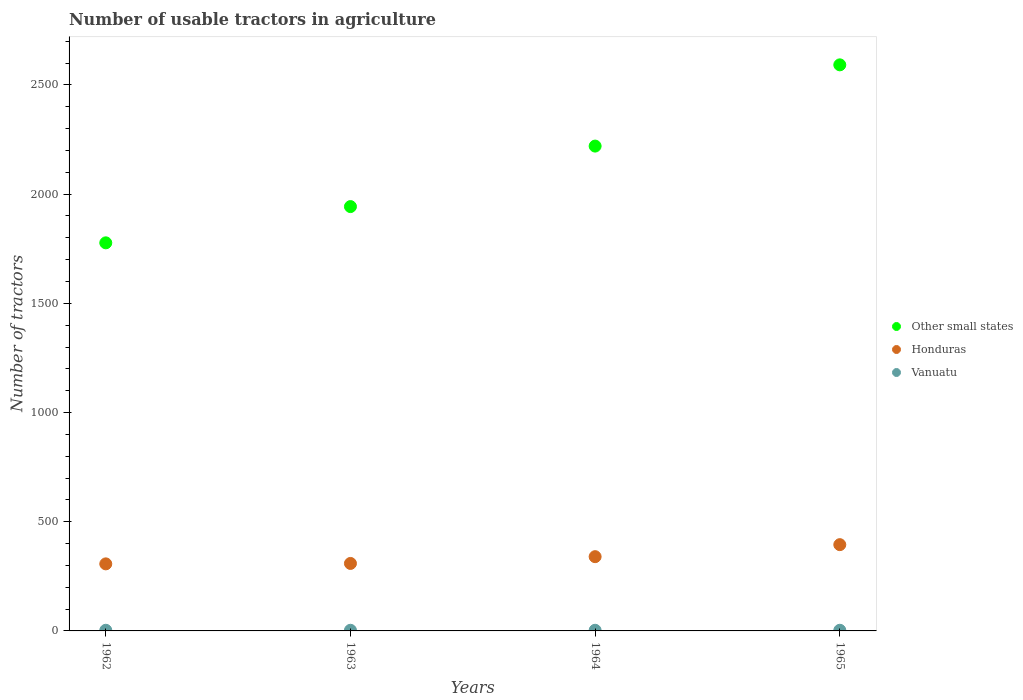How many different coloured dotlines are there?
Offer a terse response. 3. What is the number of usable tractors in agriculture in Other small states in 1964?
Your answer should be compact. 2220. Across all years, what is the maximum number of usable tractors in agriculture in Vanuatu?
Ensure brevity in your answer.  3. In which year was the number of usable tractors in agriculture in Vanuatu maximum?
Provide a succinct answer. 1962. What is the total number of usable tractors in agriculture in Vanuatu in the graph?
Give a very brief answer. 12. What is the difference between the number of usable tractors in agriculture in Honduras in 1964 and that in 1965?
Your answer should be compact. -55. What is the difference between the number of usable tractors in agriculture in Honduras in 1965 and the number of usable tractors in agriculture in Other small states in 1964?
Your answer should be compact. -1825. What is the average number of usable tractors in agriculture in Other small states per year?
Provide a short and direct response. 2133. In the year 1962, what is the difference between the number of usable tractors in agriculture in Other small states and number of usable tractors in agriculture in Vanuatu?
Offer a terse response. 1774. In how many years, is the number of usable tractors in agriculture in Other small states greater than 100?
Your answer should be very brief. 4. What is the ratio of the number of usable tractors in agriculture in Other small states in 1963 to that in 1965?
Make the answer very short. 0.75. Is the number of usable tractors in agriculture in Other small states in 1962 less than that in 1964?
Offer a terse response. Yes. What is the difference between the highest and the second highest number of usable tractors in agriculture in Other small states?
Offer a very short reply. 372. Is it the case that in every year, the sum of the number of usable tractors in agriculture in Vanuatu and number of usable tractors in agriculture in Other small states  is greater than the number of usable tractors in agriculture in Honduras?
Keep it short and to the point. Yes. Does the number of usable tractors in agriculture in Honduras monotonically increase over the years?
Your answer should be compact. Yes. Is the number of usable tractors in agriculture in Honduras strictly greater than the number of usable tractors in agriculture in Vanuatu over the years?
Ensure brevity in your answer.  Yes. How many dotlines are there?
Give a very brief answer. 3. Does the graph contain any zero values?
Give a very brief answer. No. Does the graph contain grids?
Keep it short and to the point. No. Where does the legend appear in the graph?
Make the answer very short. Center right. What is the title of the graph?
Provide a succinct answer. Number of usable tractors in agriculture. What is the label or title of the Y-axis?
Your response must be concise. Number of tractors. What is the Number of tractors of Other small states in 1962?
Ensure brevity in your answer.  1777. What is the Number of tractors of Honduras in 1962?
Provide a succinct answer. 307. What is the Number of tractors in Other small states in 1963?
Keep it short and to the point. 1943. What is the Number of tractors in Honduras in 1963?
Offer a very short reply. 309. What is the Number of tractors in Vanuatu in 1963?
Offer a very short reply. 3. What is the Number of tractors of Other small states in 1964?
Keep it short and to the point. 2220. What is the Number of tractors of Honduras in 1964?
Provide a succinct answer. 340. What is the Number of tractors in Other small states in 1965?
Keep it short and to the point. 2592. What is the Number of tractors in Honduras in 1965?
Your response must be concise. 395. What is the Number of tractors in Vanuatu in 1965?
Provide a short and direct response. 3. Across all years, what is the maximum Number of tractors of Other small states?
Make the answer very short. 2592. Across all years, what is the maximum Number of tractors in Honduras?
Ensure brevity in your answer.  395. Across all years, what is the minimum Number of tractors of Other small states?
Provide a short and direct response. 1777. Across all years, what is the minimum Number of tractors of Honduras?
Make the answer very short. 307. Across all years, what is the minimum Number of tractors of Vanuatu?
Provide a short and direct response. 3. What is the total Number of tractors in Other small states in the graph?
Your answer should be very brief. 8532. What is the total Number of tractors of Honduras in the graph?
Make the answer very short. 1351. What is the total Number of tractors of Vanuatu in the graph?
Make the answer very short. 12. What is the difference between the Number of tractors of Other small states in 1962 and that in 1963?
Give a very brief answer. -166. What is the difference between the Number of tractors of Vanuatu in 1962 and that in 1963?
Your answer should be very brief. 0. What is the difference between the Number of tractors of Other small states in 1962 and that in 1964?
Provide a short and direct response. -443. What is the difference between the Number of tractors in Honduras in 1962 and that in 1964?
Provide a succinct answer. -33. What is the difference between the Number of tractors of Vanuatu in 1962 and that in 1964?
Your answer should be compact. 0. What is the difference between the Number of tractors in Other small states in 1962 and that in 1965?
Your response must be concise. -815. What is the difference between the Number of tractors in Honduras in 1962 and that in 1965?
Offer a very short reply. -88. What is the difference between the Number of tractors of Vanuatu in 1962 and that in 1965?
Keep it short and to the point. 0. What is the difference between the Number of tractors of Other small states in 1963 and that in 1964?
Offer a terse response. -277. What is the difference between the Number of tractors of Honduras in 1963 and that in 1964?
Ensure brevity in your answer.  -31. What is the difference between the Number of tractors of Vanuatu in 1963 and that in 1964?
Offer a very short reply. 0. What is the difference between the Number of tractors in Other small states in 1963 and that in 1965?
Provide a short and direct response. -649. What is the difference between the Number of tractors in Honduras in 1963 and that in 1965?
Your answer should be very brief. -86. What is the difference between the Number of tractors of Vanuatu in 1963 and that in 1965?
Provide a succinct answer. 0. What is the difference between the Number of tractors in Other small states in 1964 and that in 1965?
Offer a very short reply. -372. What is the difference between the Number of tractors of Honduras in 1964 and that in 1965?
Ensure brevity in your answer.  -55. What is the difference between the Number of tractors in Other small states in 1962 and the Number of tractors in Honduras in 1963?
Your response must be concise. 1468. What is the difference between the Number of tractors of Other small states in 1962 and the Number of tractors of Vanuatu in 1963?
Your response must be concise. 1774. What is the difference between the Number of tractors in Honduras in 1962 and the Number of tractors in Vanuatu in 1963?
Keep it short and to the point. 304. What is the difference between the Number of tractors in Other small states in 1962 and the Number of tractors in Honduras in 1964?
Offer a terse response. 1437. What is the difference between the Number of tractors of Other small states in 1962 and the Number of tractors of Vanuatu in 1964?
Give a very brief answer. 1774. What is the difference between the Number of tractors in Honduras in 1962 and the Number of tractors in Vanuatu in 1964?
Provide a succinct answer. 304. What is the difference between the Number of tractors in Other small states in 1962 and the Number of tractors in Honduras in 1965?
Give a very brief answer. 1382. What is the difference between the Number of tractors in Other small states in 1962 and the Number of tractors in Vanuatu in 1965?
Your answer should be compact. 1774. What is the difference between the Number of tractors in Honduras in 1962 and the Number of tractors in Vanuatu in 1965?
Offer a very short reply. 304. What is the difference between the Number of tractors in Other small states in 1963 and the Number of tractors in Honduras in 1964?
Offer a terse response. 1603. What is the difference between the Number of tractors in Other small states in 1963 and the Number of tractors in Vanuatu in 1964?
Your answer should be compact. 1940. What is the difference between the Number of tractors of Honduras in 1963 and the Number of tractors of Vanuatu in 1964?
Your response must be concise. 306. What is the difference between the Number of tractors of Other small states in 1963 and the Number of tractors of Honduras in 1965?
Provide a short and direct response. 1548. What is the difference between the Number of tractors in Other small states in 1963 and the Number of tractors in Vanuatu in 1965?
Your answer should be very brief. 1940. What is the difference between the Number of tractors in Honduras in 1963 and the Number of tractors in Vanuatu in 1965?
Your response must be concise. 306. What is the difference between the Number of tractors of Other small states in 1964 and the Number of tractors of Honduras in 1965?
Your answer should be very brief. 1825. What is the difference between the Number of tractors of Other small states in 1964 and the Number of tractors of Vanuatu in 1965?
Give a very brief answer. 2217. What is the difference between the Number of tractors of Honduras in 1964 and the Number of tractors of Vanuatu in 1965?
Keep it short and to the point. 337. What is the average Number of tractors of Other small states per year?
Offer a very short reply. 2133. What is the average Number of tractors of Honduras per year?
Make the answer very short. 337.75. What is the average Number of tractors of Vanuatu per year?
Offer a terse response. 3. In the year 1962, what is the difference between the Number of tractors in Other small states and Number of tractors in Honduras?
Make the answer very short. 1470. In the year 1962, what is the difference between the Number of tractors of Other small states and Number of tractors of Vanuatu?
Keep it short and to the point. 1774. In the year 1962, what is the difference between the Number of tractors of Honduras and Number of tractors of Vanuatu?
Your response must be concise. 304. In the year 1963, what is the difference between the Number of tractors in Other small states and Number of tractors in Honduras?
Offer a very short reply. 1634. In the year 1963, what is the difference between the Number of tractors in Other small states and Number of tractors in Vanuatu?
Ensure brevity in your answer.  1940. In the year 1963, what is the difference between the Number of tractors in Honduras and Number of tractors in Vanuatu?
Keep it short and to the point. 306. In the year 1964, what is the difference between the Number of tractors of Other small states and Number of tractors of Honduras?
Offer a very short reply. 1880. In the year 1964, what is the difference between the Number of tractors of Other small states and Number of tractors of Vanuatu?
Keep it short and to the point. 2217. In the year 1964, what is the difference between the Number of tractors in Honduras and Number of tractors in Vanuatu?
Your answer should be compact. 337. In the year 1965, what is the difference between the Number of tractors of Other small states and Number of tractors of Honduras?
Give a very brief answer. 2197. In the year 1965, what is the difference between the Number of tractors in Other small states and Number of tractors in Vanuatu?
Offer a very short reply. 2589. In the year 1965, what is the difference between the Number of tractors of Honduras and Number of tractors of Vanuatu?
Offer a very short reply. 392. What is the ratio of the Number of tractors in Other small states in 1962 to that in 1963?
Make the answer very short. 0.91. What is the ratio of the Number of tractors of Honduras in 1962 to that in 1963?
Your answer should be very brief. 0.99. What is the ratio of the Number of tractors in Other small states in 1962 to that in 1964?
Your answer should be compact. 0.8. What is the ratio of the Number of tractors in Honduras in 1962 to that in 1964?
Give a very brief answer. 0.9. What is the ratio of the Number of tractors in Other small states in 1962 to that in 1965?
Keep it short and to the point. 0.69. What is the ratio of the Number of tractors of Honduras in 1962 to that in 1965?
Your response must be concise. 0.78. What is the ratio of the Number of tractors in Other small states in 1963 to that in 1964?
Your answer should be compact. 0.88. What is the ratio of the Number of tractors in Honduras in 1963 to that in 1964?
Offer a very short reply. 0.91. What is the ratio of the Number of tractors of Other small states in 1963 to that in 1965?
Make the answer very short. 0.75. What is the ratio of the Number of tractors in Honduras in 1963 to that in 1965?
Your answer should be compact. 0.78. What is the ratio of the Number of tractors of Other small states in 1964 to that in 1965?
Give a very brief answer. 0.86. What is the ratio of the Number of tractors of Honduras in 1964 to that in 1965?
Provide a succinct answer. 0.86. What is the difference between the highest and the second highest Number of tractors in Other small states?
Make the answer very short. 372. What is the difference between the highest and the second highest Number of tractors in Honduras?
Your response must be concise. 55. What is the difference between the highest and the second highest Number of tractors in Vanuatu?
Keep it short and to the point. 0. What is the difference between the highest and the lowest Number of tractors in Other small states?
Your response must be concise. 815. What is the difference between the highest and the lowest Number of tractors of Honduras?
Keep it short and to the point. 88. 